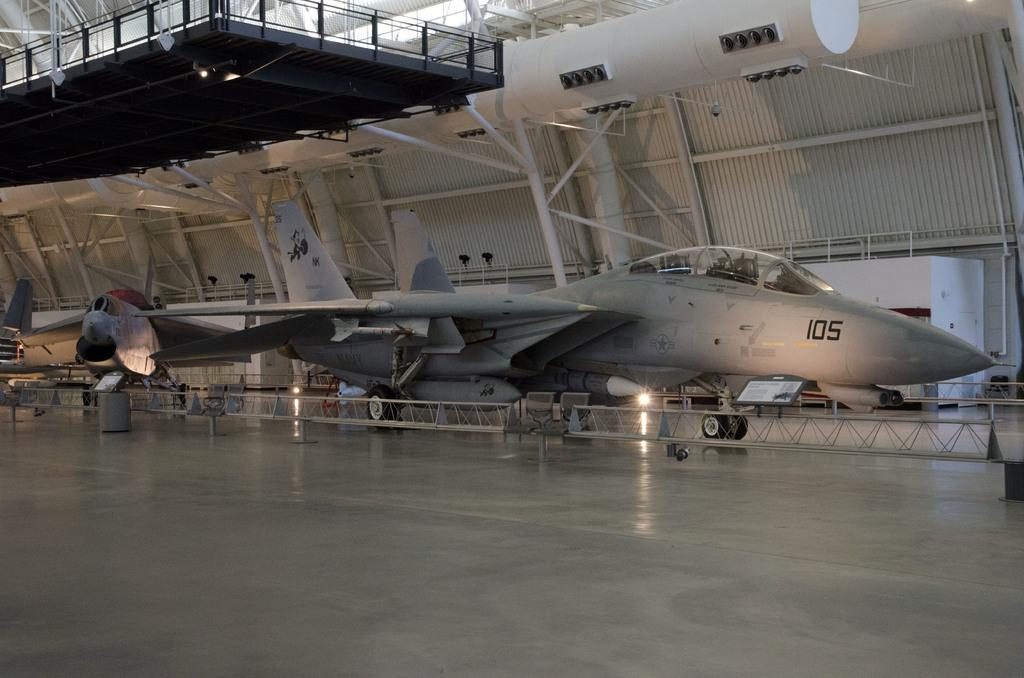<image>
Summarize the visual content of the image. An aircraft with the numbers 105 at the nose 